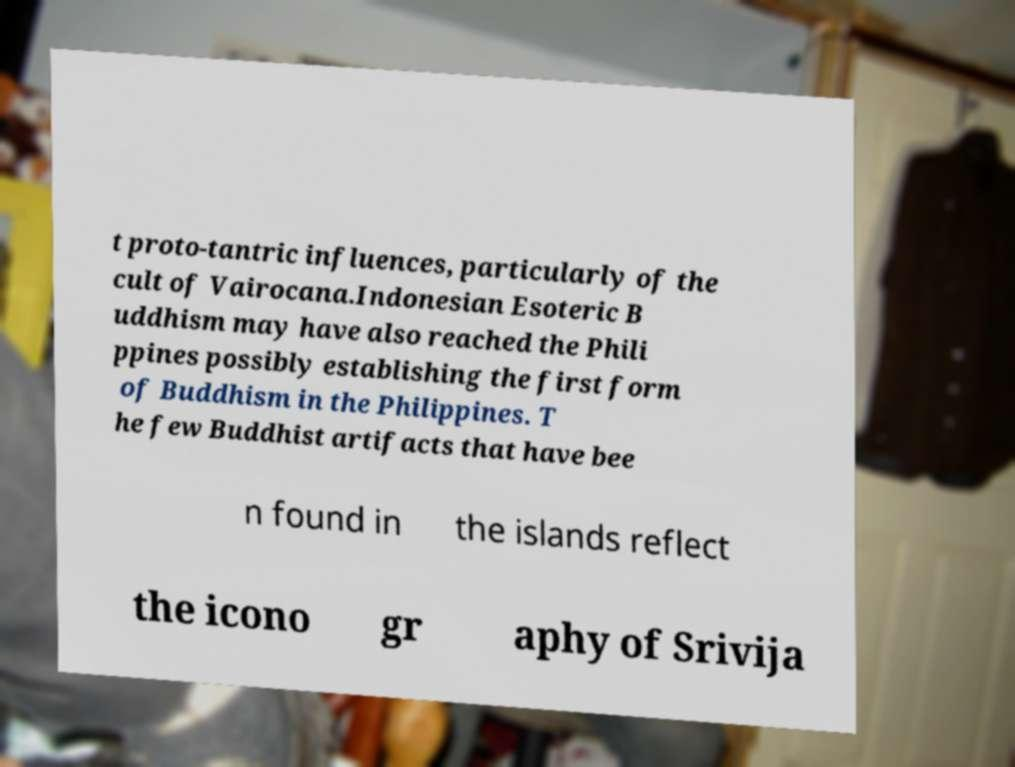Could you extract and type out the text from this image? t proto-tantric influences, particularly of the cult of Vairocana.Indonesian Esoteric B uddhism may have also reached the Phili ppines possibly establishing the first form of Buddhism in the Philippines. T he few Buddhist artifacts that have bee n found in the islands reflect the icono gr aphy of Srivija 